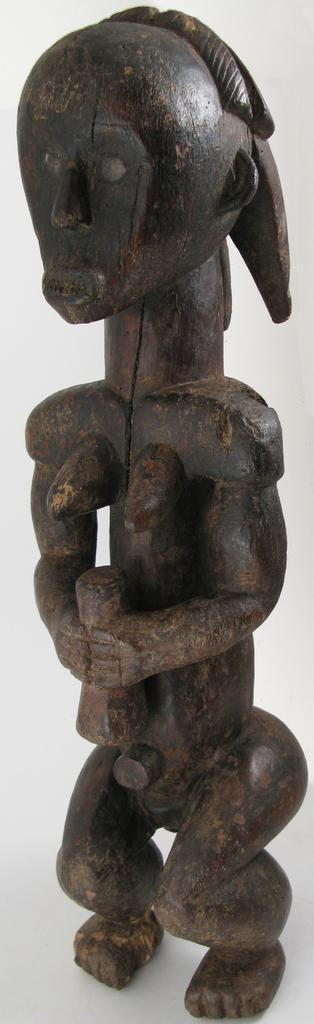What is the main subject of the image? There is a sculpture in the image. What color is the background of the image? The background of the image is white. What type of watch is the sculpture wearing in the image? There is no watch visible on the sculpture in the image. How many forks are present in the image? There are no forks present in the image. 